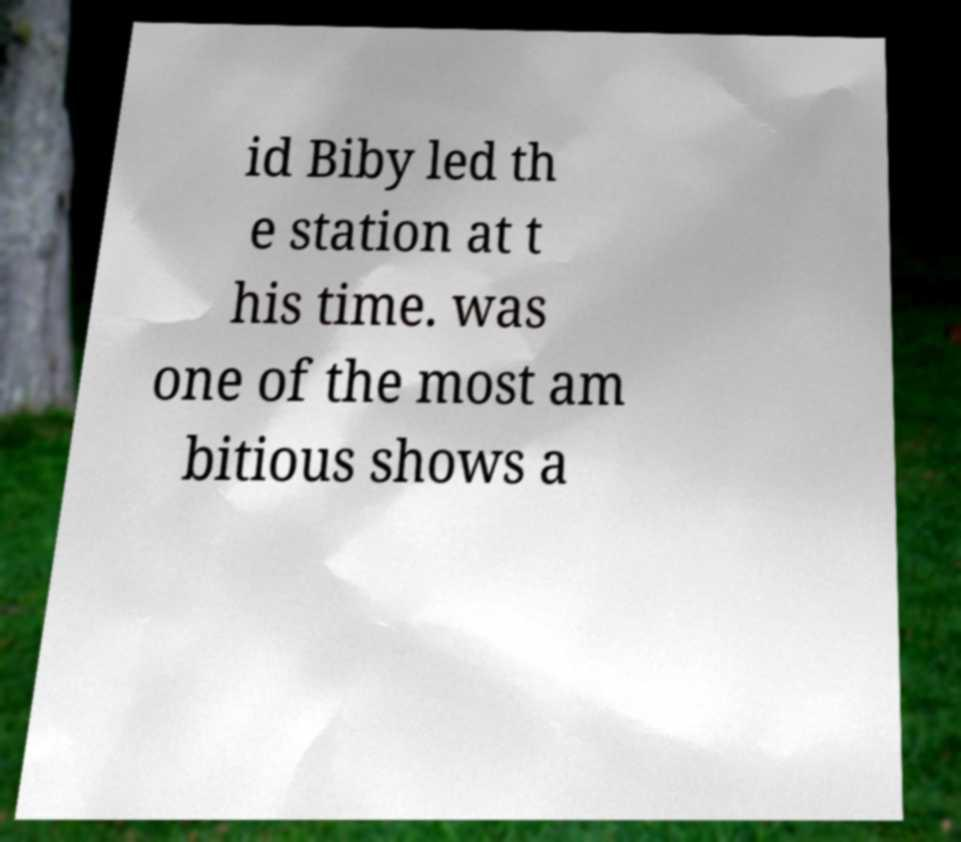Could you extract and type out the text from this image? id Biby led th e station at t his time. was one of the most am bitious shows a 